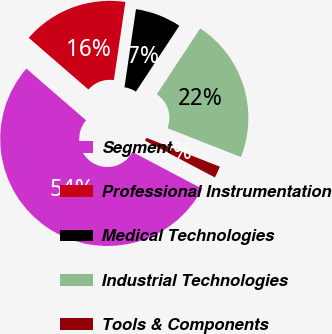Convert chart. <chart><loc_0><loc_0><loc_500><loc_500><pie_chart><fcel>Segment<fcel>Professional Instrumentation<fcel>Medical Technologies<fcel>Industrial Technologies<fcel>Tools & Components<nl><fcel>53.65%<fcel>15.96%<fcel>6.95%<fcel>21.68%<fcel>1.76%<nl></chart> 